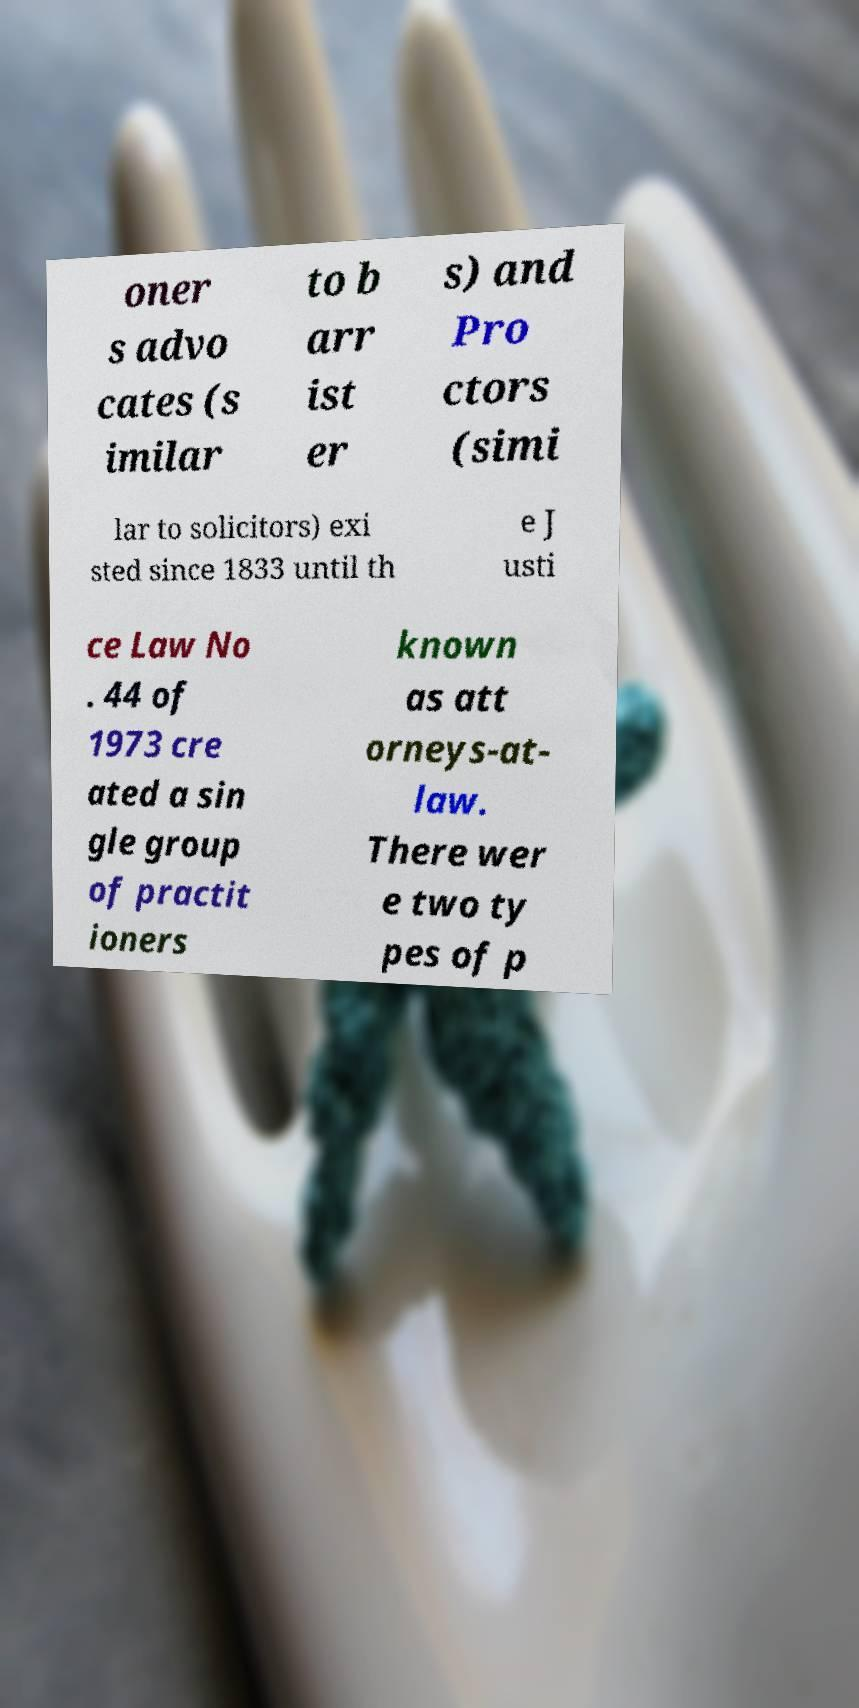Please read and relay the text visible in this image. What does it say? oner s advo cates (s imilar to b arr ist er s) and Pro ctors (simi lar to solicitors) exi sted since 1833 until th e J usti ce Law No . 44 of 1973 cre ated a sin gle group of practit ioners known as att orneys-at- law. There wer e two ty pes of p 